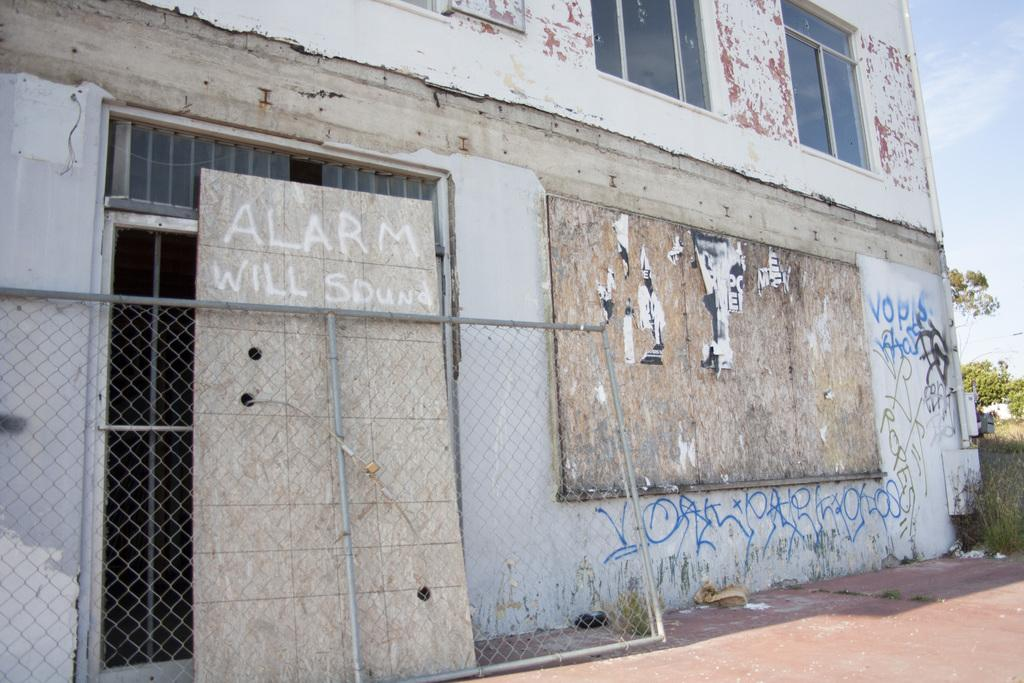What is the main feature in the foreground of the image? There is a mesh in the image. What can be seen in the background of the image? There is a building with text and trees in the background of the image. What type of vegetation is visible in the image? Grass is visible in the image. What is visible in the sky in the image? Clouds are visible in the sky. What type of jewel can be seen hanging from the mesh in the image? There is no jewel present in the image; it only features a mesh and the background elements mentioned. 